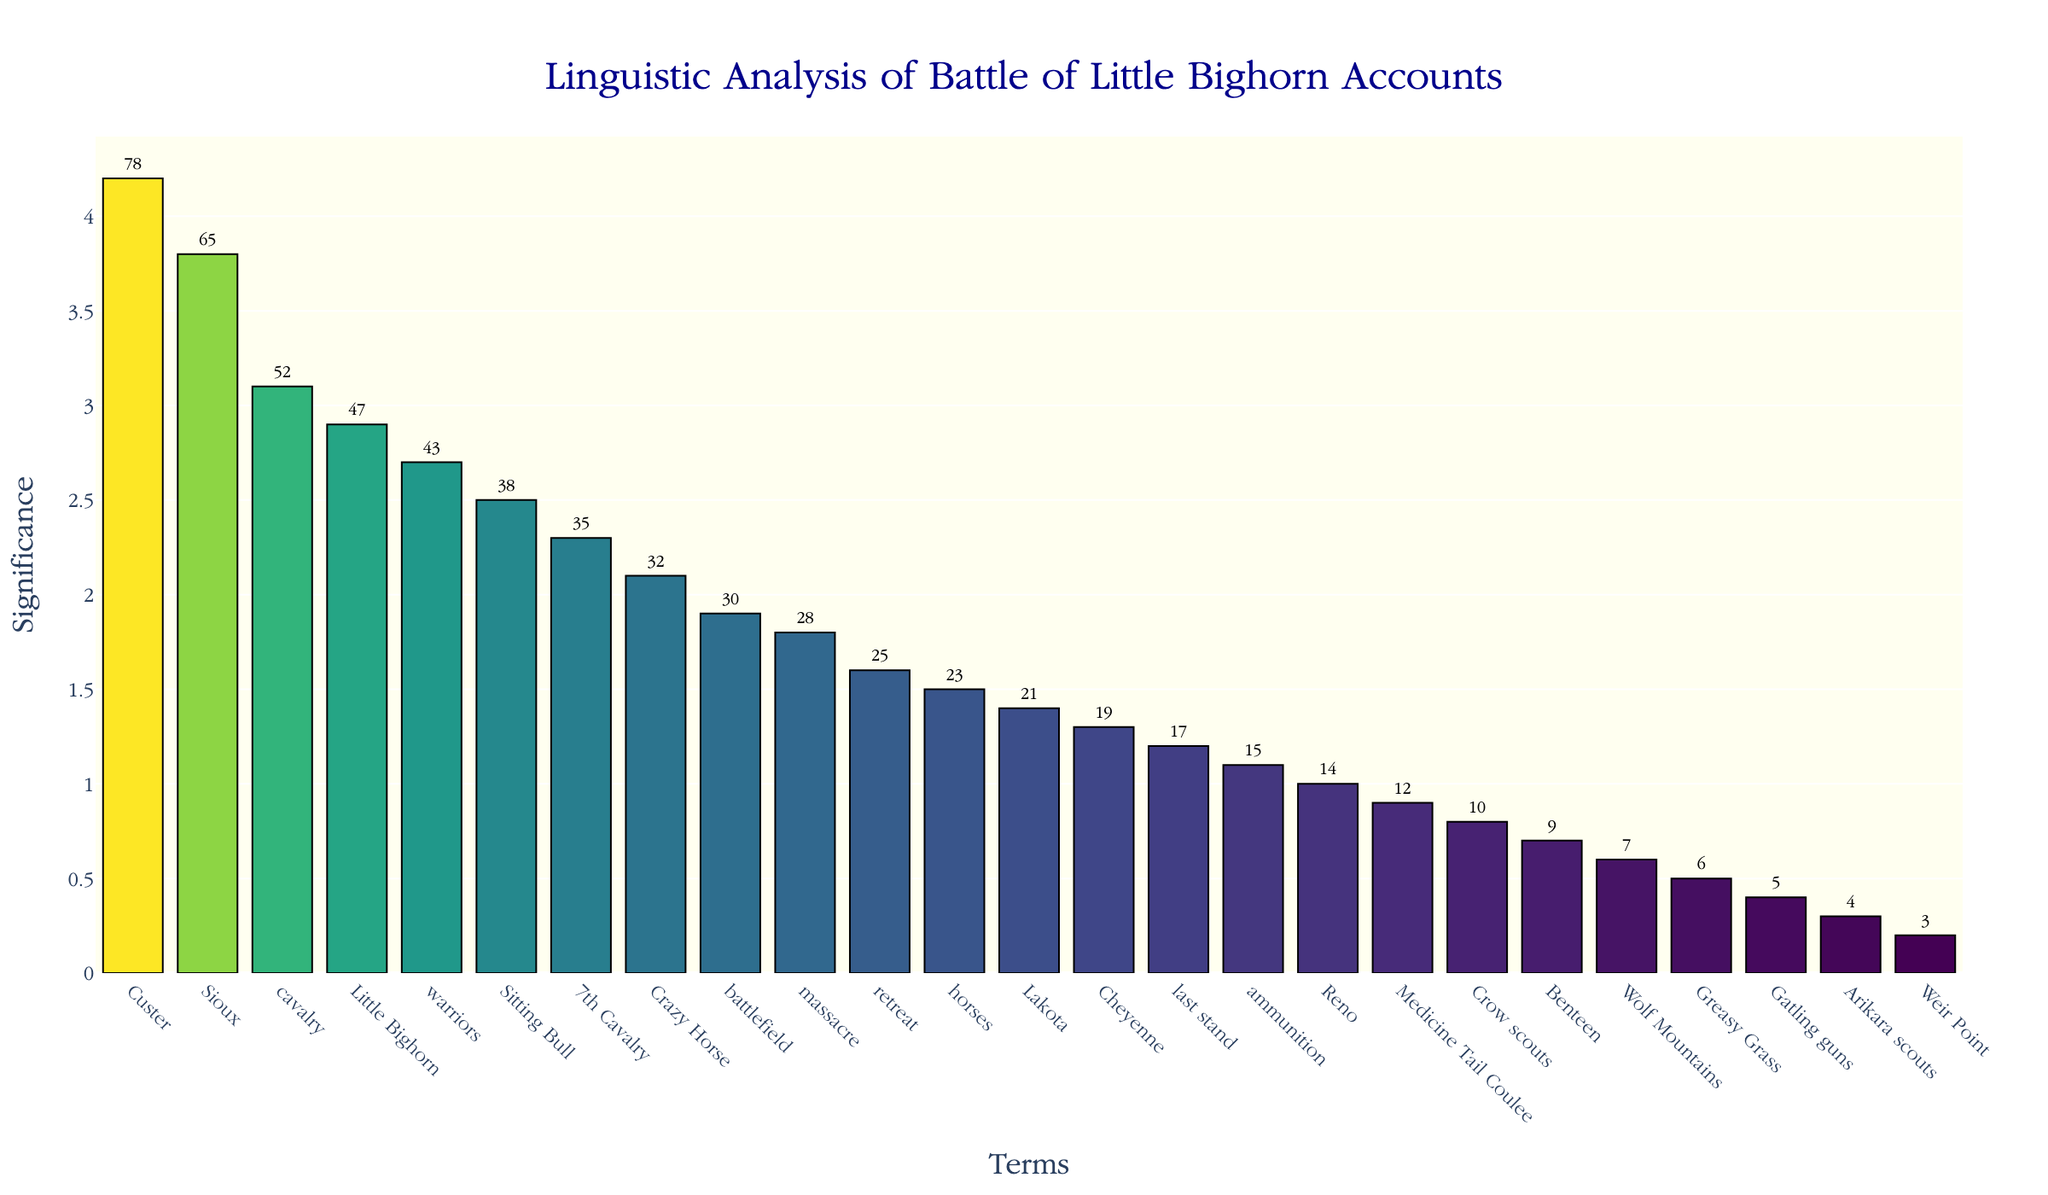What's the term with the highest significance value? The highest bar in the plot corresponds to the term with the highest significance value. The term "Custer" has the highest significance value at 4.2.
Answer: Custer Which term has the lowest frequency in the analysis? The bar with the lightest color represents the lowest frequency. "Weir Point" has the lowest frequency at 3.
Answer: Weir Point How many terms have significance values greater than 3? To determine this, count all the bars whose significance values exceed 3. The terms with significance values greater than 3 are "Custer" and "Sioux."
Answer: 2 What's the frequent term related to Native American leaders? Look for terms tagged with Native American leaders' names or titles and identify their frequencies. "Sitting Bull" has a frequency of 38 and is directly related to a Native American leader.
Answer: Sitting Bull What's the significance difference between "7th Cavalry" and "battlefield"? Subtract the significance value of "battlefield" from that of "7th Cavalry." The significance for "7th Cavalry" is 2.3 and for "battlefield" is 1.9. The difference is 2.3 - 1.9 = 0.4.
Answer: 0.4 What is the combined frequency of terms "Custer," "Sioux," and "cavalry"? Sum up the frequencies of these terms. The frequency of "Custer" is 78, "Sioux" is 65, and "cavalry" is 52. Their combined frequency is 78 + 65 + 52 = 195.
Answer: 195 Which has a higher significance value, "Lakota" or "Cheyenne"? Compare the significance values of "Lakota" and "Cheyenne." "Lakota" has a significance value of 1.4 while "Cheyenne" has 1.3. "Lakota" has a higher significance value.
Answer: Lakota What term appears just below "warriors" in significance? Identify the term listed directly below "warriors," which has a significance value of 2.7. The next term is "Sitting Bull" with a significance value of 2.5.
Answer: Sitting Bull How many terms have frequencies in the range of 20 to 40? Identify and count the terms whose frequencies fall between 20 and 40. The terms are "Sitting Bull," "7th Cavalry," "Crazy Horse," "battlefield," "massacre," "retreat," and "horses." There are 7 such terms.
Answer: 7 